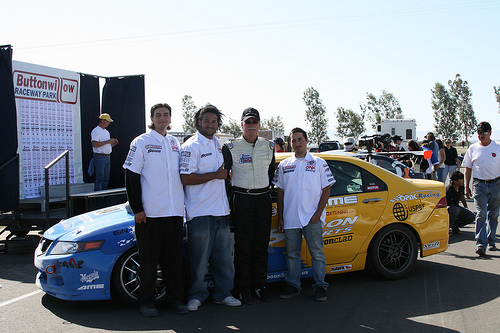<image>
Can you confirm if the car is behind the man? Yes. From this viewpoint, the car is positioned behind the man, with the man partially or fully occluding the car. Is the car behind the man? Yes. From this viewpoint, the car is positioned behind the man, with the man partially or fully occluding the car. Where is the big boy in relation to the small boy? Is it to the right of the small boy? No. The big boy is not to the right of the small boy. The horizontal positioning shows a different relationship. Is there a man in front of the car? Yes. The man is positioned in front of the car, appearing closer to the camera viewpoint. 